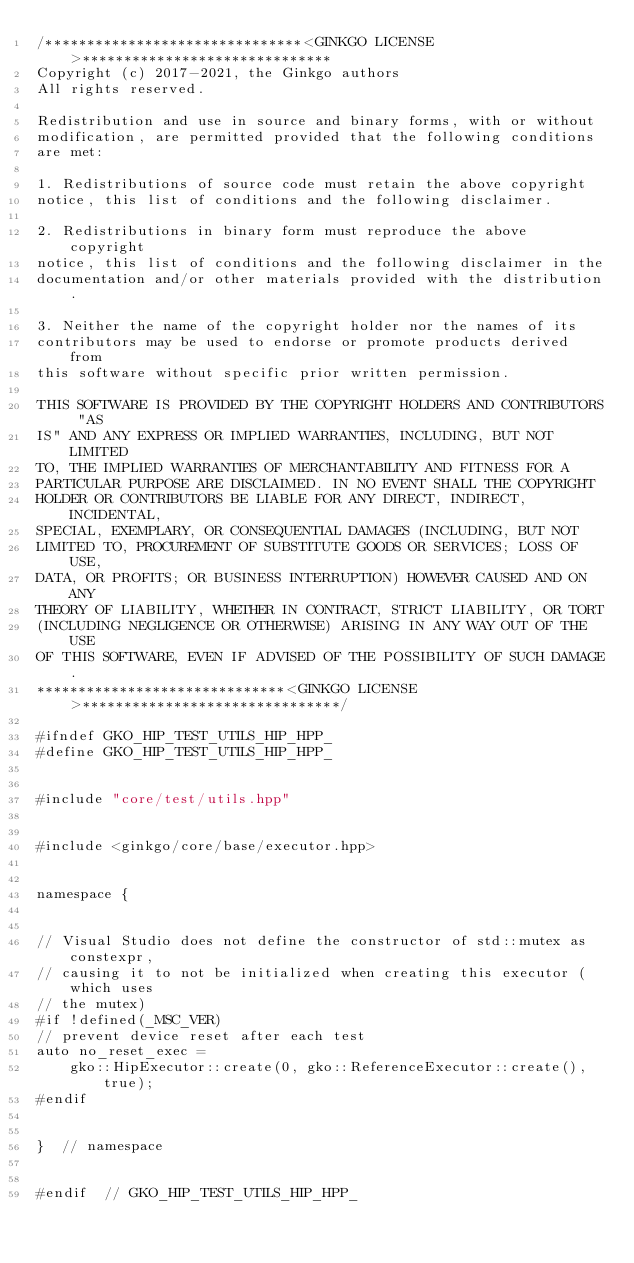Convert code to text. <code><loc_0><loc_0><loc_500><loc_500><_C++_>/*******************************<GINKGO LICENSE>******************************
Copyright (c) 2017-2021, the Ginkgo authors
All rights reserved.

Redistribution and use in source and binary forms, with or without
modification, are permitted provided that the following conditions
are met:

1. Redistributions of source code must retain the above copyright
notice, this list of conditions and the following disclaimer.

2. Redistributions in binary form must reproduce the above copyright
notice, this list of conditions and the following disclaimer in the
documentation and/or other materials provided with the distribution.

3. Neither the name of the copyright holder nor the names of its
contributors may be used to endorse or promote products derived from
this software without specific prior written permission.

THIS SOFTWARE IS PROVIDED BY THE COPYRIGHT HOLDERS AND CONTRIBUTORS "AS
IS" AND ANY EXPRESS OR IMPLIED WARRANTIES, INCLUDING, BUT NOT LIMITED
TO, THE IMPLIED WARRANTIES OF MERCHANTABILITY AND FITNESS FOR A
PARTICULAR PURPOSE ARE DISCLAIMED. IN NO EVENT SHALL THE COPYRIGHT
HOLDER OR CONTRIBUTORS BE LIABLE FOR ANY DIRECT, INDIRECT, INCIDENTAL,
SPECIAL, EXEMPLARY, OR CONSEQUENTIAL DAMAGES (INCLUDING, BUT NOT
LIMITED TO, PROCUREMENT OF SUBSTITUTE GOODS OR SERVICES; LOSS OF USE,
DATA, OR PROFITS; OR BUSINESS INTERRUPTION) HOWEVER CAUSED AND ON ANY
THEORY OF LIABILITY, WHETHER IN CONTRACT, STRICT LIABILITY, OR TORT
(INCLUDING NEGLIGENCE OR OTHERWISE) ARISING IN ANY WAY OUT OF THE USE
OF THIS SOFTWARE, EVEN IF ADVISED OF THE POSSIBILITY OF SUCH DAMAGE.
******************************<GINKGO LICENSE>*******************************/

#ifndef GKO_HIP_TEST_UTILS_HIP_HPP_
#define GKO_HIP_TEST_UTILS_HIP_HPP_


#include "core/test/utils.hpp"


#include <ginkgo/core/base/executor.hpp>


namespace {


// Visual Studio does not define the constructor of std::mutex as constexpr,
// causing it to not be initialized when creating this executor (which uses
// the mutex)
#if !defined(_MSC_VER)
// prevent device reset after each test
auto no_reset_exec =
    gko::HipExecutor::create(0, gko::ReferenceExecutor::create(), true);
#endif


}  // namespace


#endif  // GKO_HIP_TEST_UTILS_HIP_HPP_
</code> 